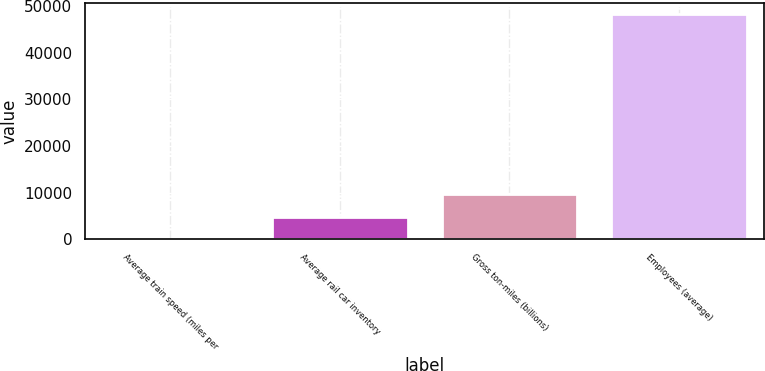Convert chart to OTSL. <chart><loc_0><loc_0><loc_500><loc_500><bar_chart><fcel>Average train speed (miles per<fcel>Average rail car inventory<fcel>Gross ton-miles (billions)<fcel>Employees (average)<nl><fcel>23.5<fcel>4845.35<fcel>9667.2<fcel>48242<nl></chart> 